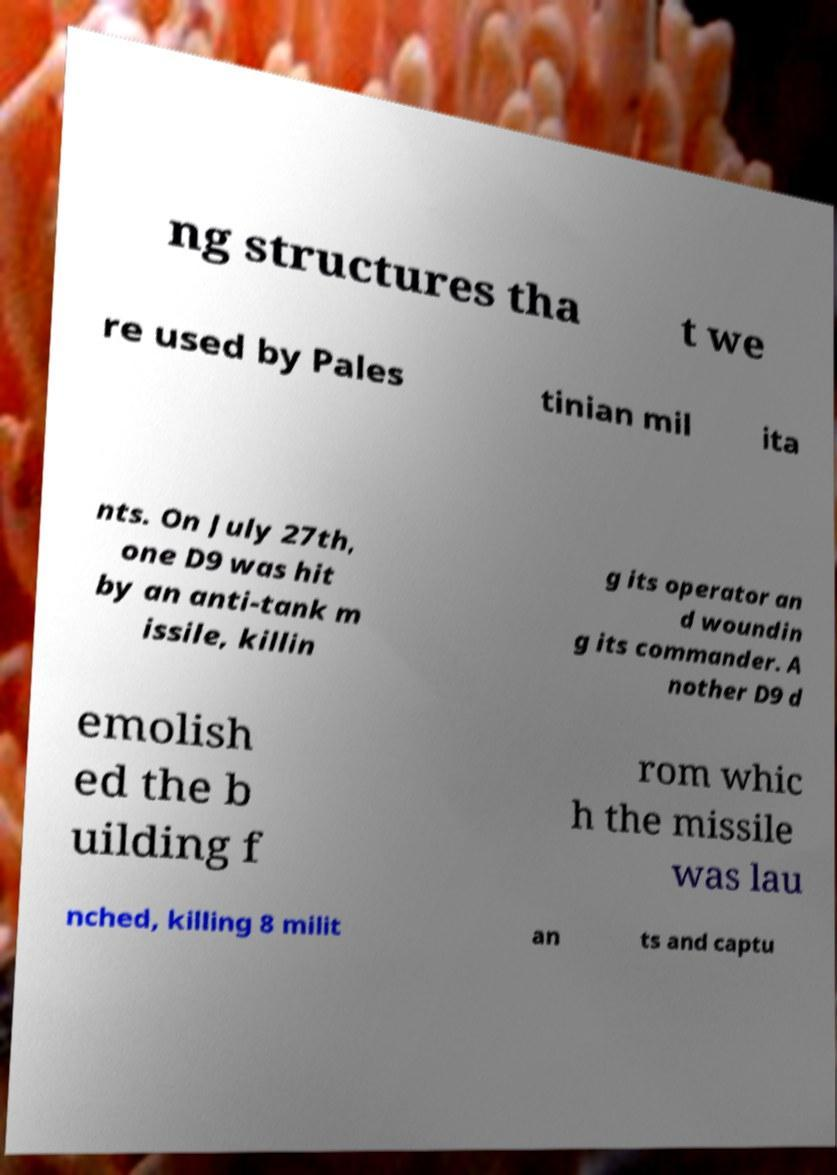For documentation purposes, I need the text within this image transcribed. Could you provide that? ng structures tha t we re used by Pales tinian mil ita nts. On July 27th, one D9 was hit by an anti-tank m issile, killin g its operator an d woundin g its commander. A nother D9 d emolish ed the b uilding f rom whic h the missile was lau nched, killing 8 milit an ts and captu 